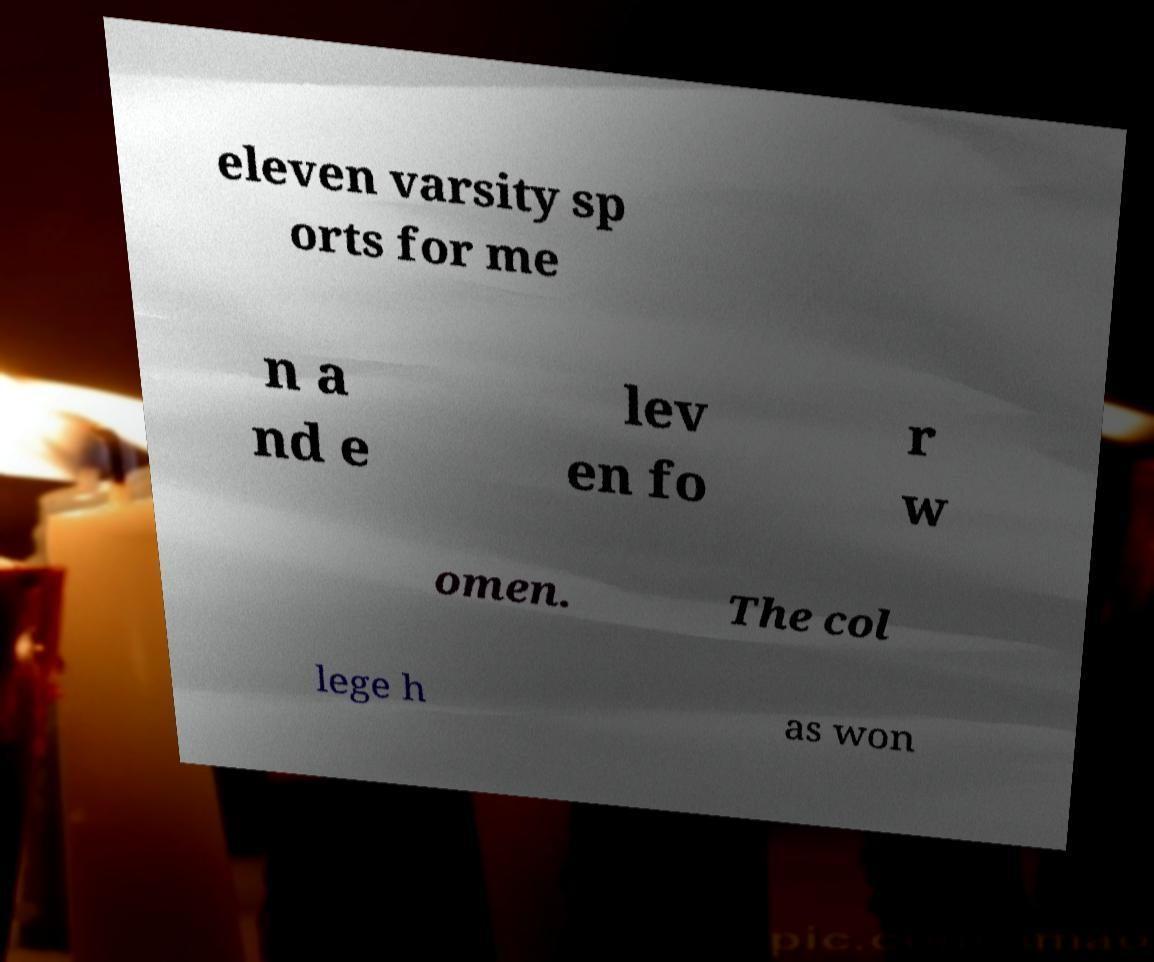Can you read and provide the text displayed in the image?This photo seems to have some interesting text. Can you extract and type it out for me? eleven varsity sp orts for me n a nd e lev en fo r w omen. The col lege h as won 